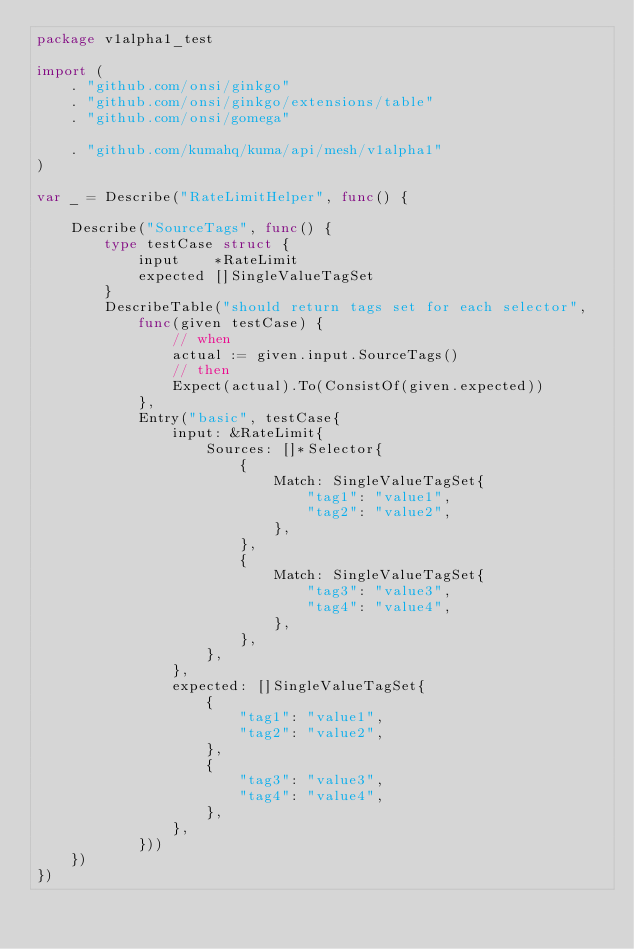<code> <loc_0><loc_0><loc_500><loc_500><_Go_>package v1alpha1_test

import (
	. "github.com/onsi/ginkgo"
	. "github.com/onsi/ginkgo/extensions/table"
	. "github.com/onsi/gomega"

	. "github.com/kumahq/kuma/api/mesh/v1alpha1"
)

var _ = Describe("RateLimitHelper", func() {

	Describe("SourceTags", func() {
		type testCase struct {
			input    *RateLimit
			expected []SingleValueTagSet
		}
		DescribeTable("should return tags set for each selector",
			func(given testCase) {
				// when
				actual := given.input.SourceTags()
				// then
				Expect(actual).To(ConsistOf(given.expected))
			},
			Entry("basic", testCase{
				input: &RateLimit{
					Sources: []*Selector{
						{
							Match: SingleValueTagSet{
								"tag1": "value1",
								"tag2": "value2",
							},
						},
						{
							Match: SingleValueTagSet{
								"tag3": "value3",
								"tag4": "value4",
							},
						},
					},
				},
				expected: []SingleValueTagSet{
					{
						"tag1": "value1",
						"tag2": "value2",
					},
					{
						"tag3": "value3",
						"tag4": "value4",
					},
				},
			}))
	})
})
</code> 